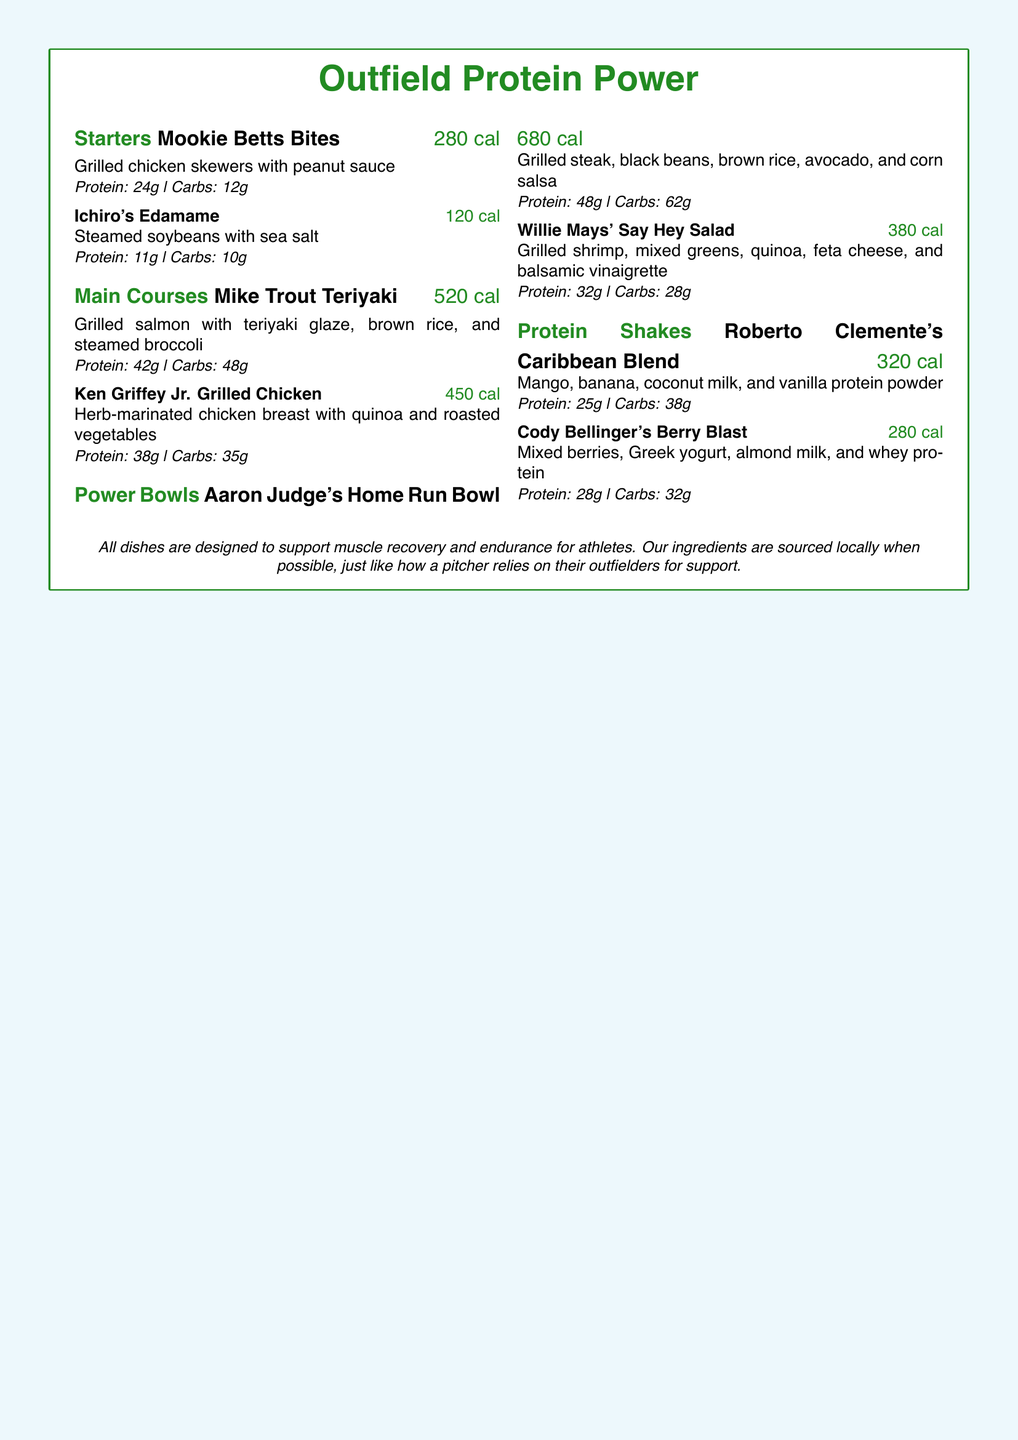What is the calorie count of Mookie Betts Bites? The calorie count for Mookie Betts Bites is stated in the menu under the dish, which is 280 cal.
Answer: 280 cal What protein content does Aaron Judge's Home Run Bowl provide? The protein content is listed in the menu for Aaron Judge's Home Run Bowl, which provides 48g of protein.
Answer: 48g Which dish has the highest calorie count? By comparing the calorie counts listed in the menu for all dishes, the one with the highest calorie count is Aaron Judge's Home Run Bowl at 680 cal.
Answer: Aaron Judge's Home Run Bowl What main course features grilled salmon? The menu specifically lists Mike Trout Teriyaki as the main course that features grilled salmon.
Answer: Mike Trout Teriyaki How many grams of carbs are in Cody Bellinger's Berry Blast? The grams of carbs for Cody Bellinger's Berry Blast are directly indicated in the menu, which is 32g.
Answer: 32g What type of dish is Ichiro's Edamame? The menu classifies Ichiro's Edamame as a starter, as seen in the section title above the dish.
Answer: Starter Which dish is made with quinoa? The dishes listed with quinoa in the description include Ken Griffey Jr. Grilled Chicken and Willie Mays' Say Hey Salad.
Answer: Ken Griffey Jr. Grilled Chicken, Willie Mays' Say Hey Salad What flavor does Roberto Clemente's Caribbean Blend have? The ingredients listed for Roberto Clemente's Caribbean Blend include mango, banana, coconut milk, and vanilla protein powder, indicating a tropical flavor.
Answer: Tropical flavor 